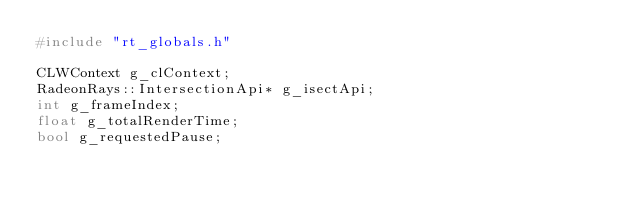<code> <loc_0><loc_0><loc_500><loc_500><_C++_>#include "rt_globals.h"

CLWContext g_clContext;
RadeonRays::IntersectionApi* g_isectApi;
int g_frameIndex;
float g_totalRenderTime;
bool g_requestedPause;</code> 